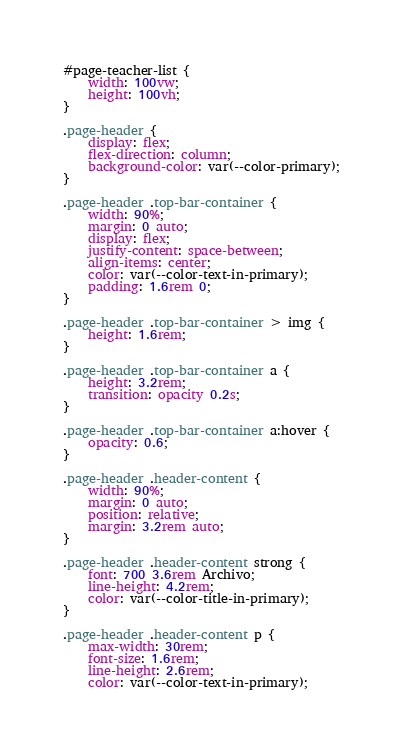Convert code to text. <code><loc_0><loc_0><loc_500><loc_500><_CSS_>#page-teacher-list {
    width: 100vw;
    height: 100vh;
}

.page-header {
    display: flex;
    flex-direction: column;
    background-color: var(--color-primary);
}

.page-header .top-bar-container {
    width: 90%;
    margin: 0 auto;
    display: flex;
    justify-content: space-between;
    align-items: center;
    color: var(--color-text-in-primary);
    padding: 1.6rem 0;
}

.page-header .top-bar-container > img {
    height: 1.6rem;
}

.page-header .top-bar-container a {
    height: 3.2rem;
    transition: opacity 0.2s;
}

.page-header .top-bar-container a:hover {
    opacity: 0.6;
}

.page-header .header-content {
    width: 90%;
    margin: 0 auto;
    position: relative;
    margin: 3.2rem auto;
}

.page-header .header-content strong {
    font: 700 3.6rem Archivo;
    line-height: 4.2rem;
    color: var(--color-title-in-primary);
}

.page-header .header-content p {
    max-width: 30rem;
    font-size: 1.6rem;
    line-height: 2.6rem;
    color: var(--color-text-in-primary);</code> 